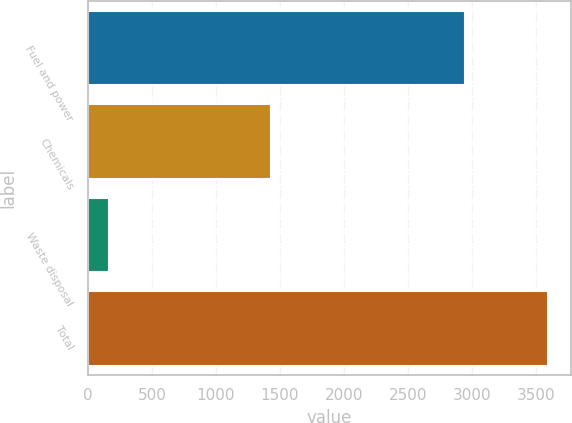<chart> <loc_0><loc_0><loc_500><loc_500><bar_chart><fcel>Fuel and power<fcel>Chemicals<fcel>Waste disposal<fcel>Total<nl><fcel>2945<fcel>1433<fcel>162<fcel>3594<nl></chart> 